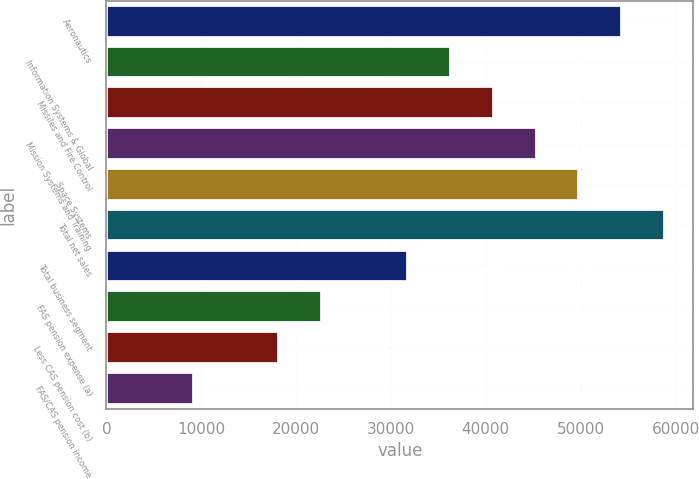Convert chart. <chart><loc_0><loc_0><loc_500><loc_500><bar_chart><fcel>Aeronautics<fcel>Information Systems & Global<fcel>Missiles and Fire Control<fcel>Mission Systems and Training<fcel>Space Systems<fcel>Total net sales<fcel>Total business segment<fcel>FAS pension expense (a)<fcel>Less CAS pension cost (b)<fcel>FAS/CAS pension income<nl><fcel>54393.6<fcel>36322.4<fcel>40840.2<fcel>45358<fcel>49875.8<fcel>58911.4<fcel>31804.6<fcel>22769<fcel>18251.2<fcel>9215.6<nl></chart> 